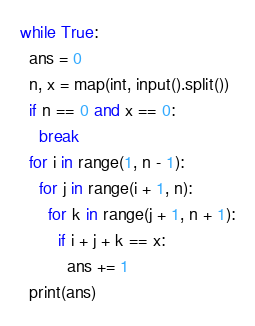<code> <loc_0><loc_0><loc_500><loc_500><_Python_>while True:
  ans = 0
  n, x = map(int, input().split())
  if n == 0 and x == 0:
    break
  for i in range(1, n - 1):
    for j in range(i + 1, n):
      for k in range(j + 1, n + 1):
        if i + j + k == x:
          ans += 1
  print(ans)
</code> 